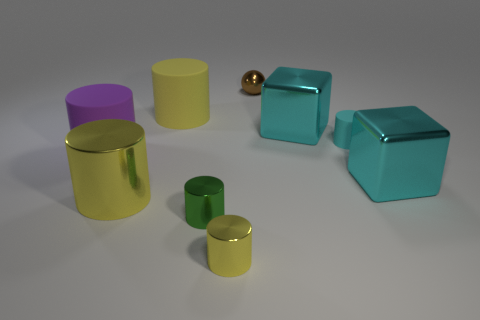Subtract all cyan matte cylinders. How many cylinders are left? 5 Add 1 big yellow rubber cylinders. How many objects exist? 10 Subtract 5 cylinders. How many cylinders are left? 1 Subtract all green cylinders. How many cylinders are left? 5 Subtract 0 red spheres. How many objects are left? 9 Subtract all spheres. How many objects are left? 8 Subtract all red balls. Subtract all purple cylinders. How many balls are left? 1 Subtract all purple cubes. How many brown cylinders are left? 0 Subtract all large green matte objects. Subtract all cylinders. How many objects are left? 3 Add 5 large rubber cylinders. How many large rubber cylinders are left? 7 